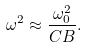<formula> <loc_0><loc_0><loc_500><loc_500>\omega ^ { 2 } \approx \frac { \omega _ { 0 } ^ { 2 } } { C B } .</formula> 